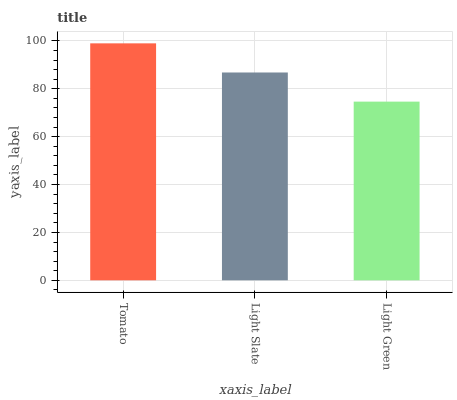Is Light Green the minimum?
Answer yes or no. Yes. Is Tomato the maximum?
Answer yes or no. Yes. Is Light Slate the minimum?
Answer yes or no. No. Is Light Slate the maximum?
Answer yes or no. No. Is Tomato greater than Light Slate?
Answer yes or no. Yes. Is Light Slate less than Tomato?
Answer yes or no. Yes. Is Light Slate greater than Tomato?
Answer yes or no. No. Is Tomato less than Light Slate?
Answer yes or no. No. Is Light Slate the high median?
Answer yes or no. Yes. Is Light Slate the low median?
Answer yes or no. Yes. Is Tomato the high median?
Answer yes or no. No. Is Tomato the low median?
Answer yes or no. No. 